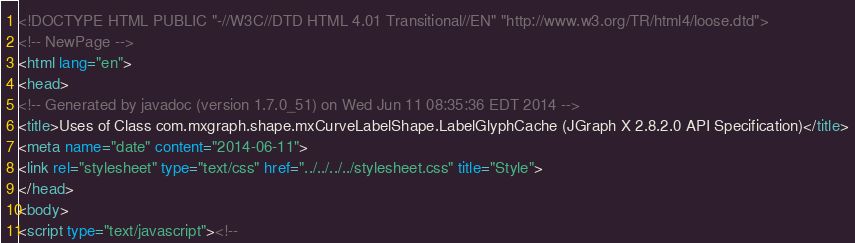<code> <loc_0><loc_0><loc_500><loc_500><_HTML_><!DOCTYPE HTML PUBLIC "-//W3C//DTD HTML 4.01 Transitional//EN" "http://www.w3.org/TR/html4/loose.dtd">
<!-- NewPage -->
<html lang="en">
<head>
<!-- Generated by javadoc (version 1.7.0_51) on Wed Jun 11 08:35:36 EDT 2014 -->
<title>Uses of Class com.mxgraph.shape.mxCurveLabelShape.LabelGlyphCache (JGraph X 2.8.2.0 API Specification)</title>
<meta name="date" content="2014-06-11">
<link rel="stylesheet" type="text/css" href="../../../../stylesheet.css" title="Style">
</head>
<body>
<script type="text/javascript"><!--</code> 